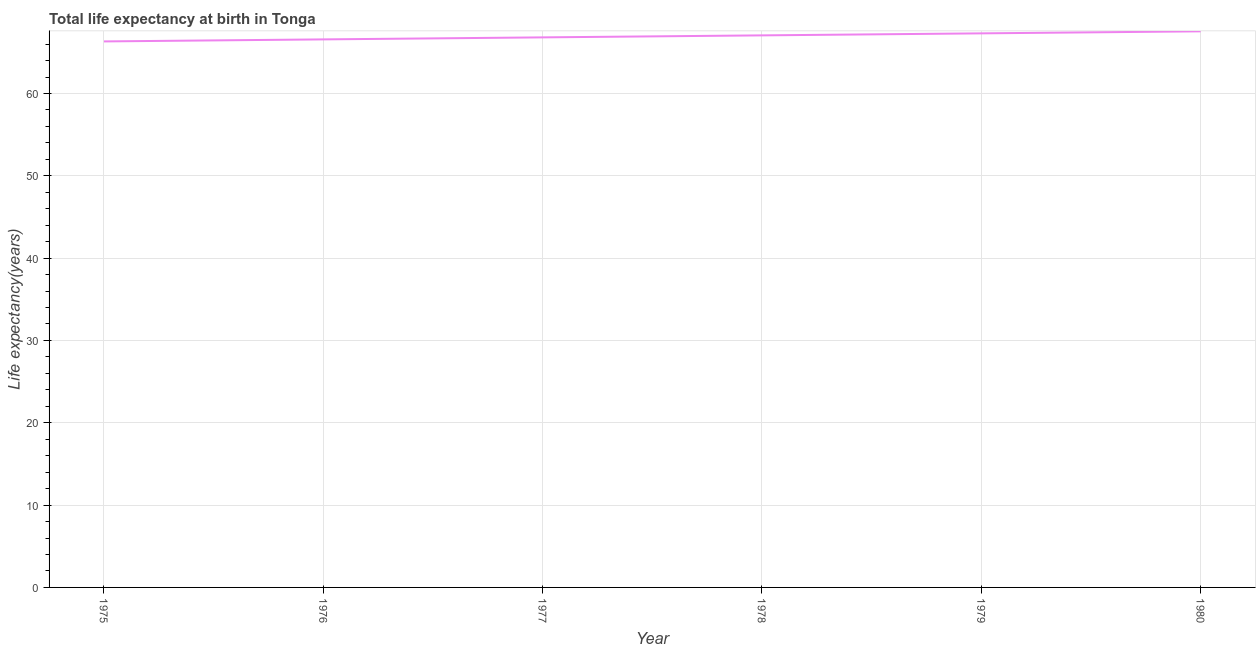What is the life expectancy at birth in 1978?
Make the answer very short. 67.06. Across all years, what is the maximum life expectancy at birth?
Give a very brief answer. 67.55. Across all years, what is the minimum life expectancy at birth?
Keep it short and to the point. 66.32. In which year was the life expectancy at birth maximum?
Give a very brief answer. 1980. In which year was the life expectancy at birth minimum?
Your response must be concise. 1975. What is the sum of the life expectancy at birth?
Provide a short and direct response. 401.62. What is the difference between the life expectancy at birth in 1975 and 1980?
Ensure brevity in your answer.  -1.23. What is the average life expectancy at birth per year?
Keep it short and to the point. 66.94. What is the median life expectancy at birth?
Offer a terse response. 66.94. In how many years, is the life expectancy at birth greater than 42 years?
Provide a succinct answer. 6. What is the ratio of the life expectancy at birth in 1976 to that in 1979?
Provide a succinct answer. 0.99. What is the difference between the highest and the second highest life expectancy at birth?
Your response must be concise. 0.25. What is the difference between the highest and the lowest life expectancy at birth?
Offer a terse response. 1.23. In how many years, is the life expectancy at birth greater than the average life expectancy at birth taken over all years?
Give a very brief answer. 3. How many lines are there?
Make the answer very short. 1. How many years are there in the graph?
Give a very brief answer. 6. Does the graph contain grids?
Offer a terse response. Yes. What is the title of the graph?
Provide a short and direct response. Total life expectancy at birth in Tonga. What is the label or title of the Y-axis?
Offer a very short reply. Life expectancy(years). What is the Life expectancy(years) in 1975?
Ensure brevity in your answer.  66.32. What is the Life expectancy(years) in 1976?
Ensure brevity in your answer.  66.57. What is the Life expectancy(years) of 1977?
Offer a very short reply. 66.82. What is the Life expectancy(years) in 1978?
Give a very brief answer. 67.06. What is the Life expectancy(years) of 1979?
Ensure brevity in your answer.  67.3. What is the Life expectancy(years) in 1980?
Make the answer very short. 67.55. What is the difference between the Life expectancy(years) in 1975 and 1976?
Offer a very short reply. -0.25. What is the difference between the Life expectancy(years) in 1975 and 1977?
Provide a short and direct response. -0.49. What is the difference between the Life expectancy(years) in 1975 and 1978?
Keep it short and to the point. -0.74. What is the difference between the Life expectancy(years) in 1975 and 1979?
Offer a very short reply. -0.98. What is the difference between the Life expectancy(years) in 1975 and 1980?
Ensure brevity in your answer.  -1.23. What is the difference between the Life expectancy(years) in 1976 and 1977?
Provide a succinct answer. -0.24. What is the difference between the Life expectancy(years) in 1976 and 1978?
Your answer should be compact. -0.49. What is the difference between the Life expectancy(years) in 1976 and 1979?
Provide a short and direct response. -0.73. What is the difference between the Life expectancy(years) in 1976 and 1980?
Make the answer very short. -0.98. What is the difference between the Life expectancy(years) in 1977 and 1978?
Your response must be concise. -0.24. What is the difference between the Life expectancy(years) in 1977 and 1979?
Provide a short and direct response. -0.49. What is the difference between the Life expectancy(years) in 1977 and 1980?
Your response must be concise. -0.73. What is the difference between the Life expectancy(years) in 1978 and 1979?
Keep it short and to the point. -0.24. What is the difference between the Life expectancy(years) in 1978 and 1980?
Provide a succinct answer. -0.49. What is the difference between the Life expectancy(years) in 1979 and 1980?
Keep it short and to the point. -0.25. What is the ratio of the Life expectancy(years) in 1975 to that in 1978?
Make the answer very short. 0.99. What is the ratio of the Life expectancy(years) in 1976 to that in 1977?
Ensure brevity in your answer.  1. What is the ratio of the Life expectancy(years) in 1976 to that in 1978?
Provide a succinct answer. 0.99. What is the ratio of the Life expectancy(years) in 1977 to that in 1979?
Provide a short and direct response. 0.99. What is the ratio of the Life expectancy(years) in 1977 to that in 1980?
Keep it short and to the point. 0.99. What is the ratio of the Life expectancy(years) in 1978 to that in 1979?
Your response must be concise. 1. What is the ratio of the Life expectancy(years) in 1979 to that in 1980?
Provide a succinct answer. 1. 